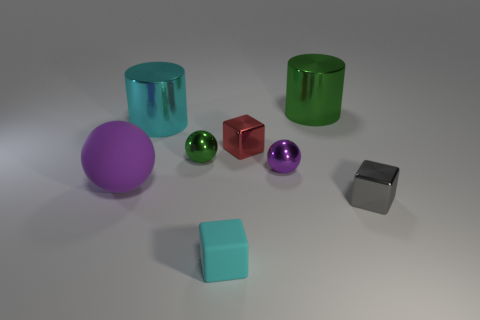What color is the small metallic thing in front of the purple rubber object?
Offer a terse response. Gray. The green metal thing that is the same size as the purple shiny object is what shape?
Offer a very short reply. Sphere. Is the color of the rubber block the same as the cylinder that is to the left of the small purple sphere?
Provide a short and direct response. Yes. What number of objects are either green objects that are to the right of the purple metal thing or tiny objects that are on the left side of the purple metal thing?
Provide a short and direct response. 4. There is a cyan cube that is the same size as the red block; what is its material?
Your response must be concise. Rubber. How many other things are there of the same material as the cyan cube?
Keep it short and to the point. 1. Do the cyan object behind the big purple matte object and the big green metal object on the right side of the tiny green metal sphere have the same shape?
Your response must be concise. Yes. There is a block that is behind the small shiny object that is on the right side of the large metal cylinder on the right side of the cyan cylinder; what is its color?
Ensure brevity in your answer.  Red. How many other objects are the same color as the tiny rubber cube?
Ensure brevity in your answer.  1. Are there fewer large purple cylinders than cyan metal things?
Your answer should be very brief. Yes. 